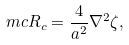<formula> <loc_0><loc_0><loc_500><loc_500>\ m c { R } _ { c } = \frac { 4 } { a ^ { 2 } } \nabla ^ { 2 } \zeta ,</formula> 